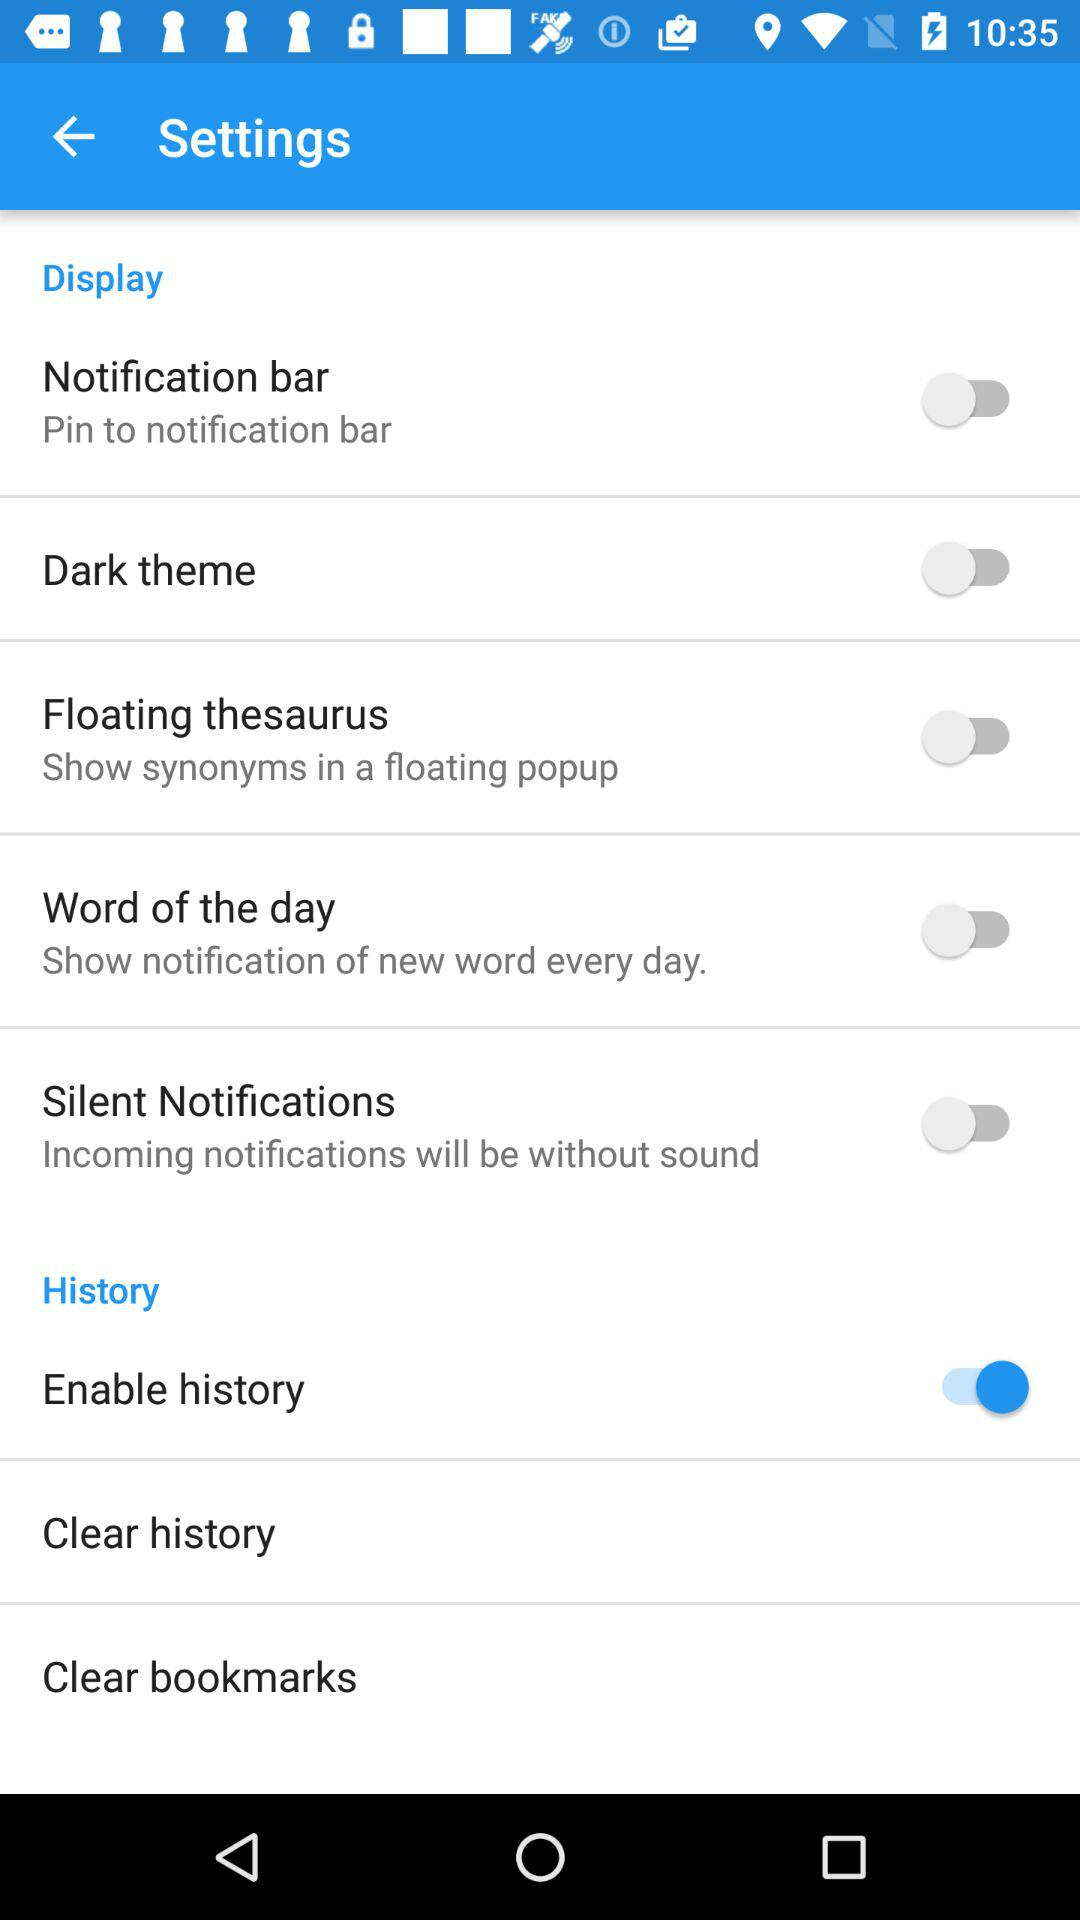What is the status of the notification bar? The status is off. 